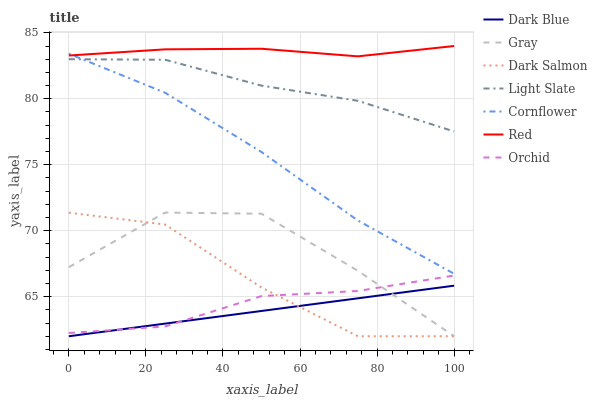Does Gray have the minimum area under the curve?
Answer yes or no. No. Does Gray have the maximum area under the curve?
Answer yes or no. No. Is Light Slate the smoothest?
Answer yes or no. No. Is Light Slate the roughest?
Answer yes or no. No. Does Light Slate have the lowest value?
Answer yes or no. No. Does Gray have the highest value?
Answer yes or no. No. Is Dark Blue less than Light Slate?
Answer yes or no. Yes. Is Cornflower greater than Dark Salmon?
Answer yes or no. Yes. Does Dark Blue intersect Light Slate?
Answer yes or no. No. 